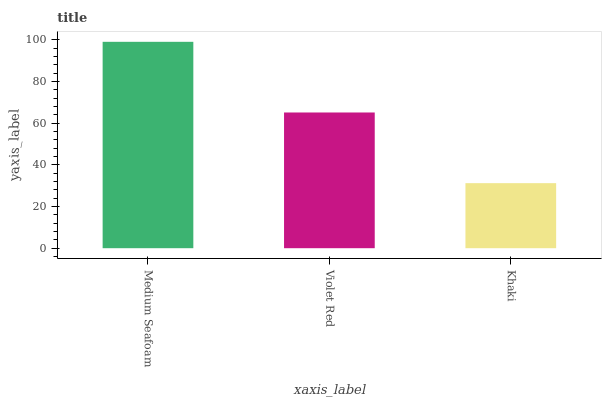Is Khaki the minimum?
Answer yes or no. Yes. Is Medium Seafoam the maximum?
Answer yes or no. Yes. Is Violet Red the minimum?
Answer yes or no. No. Is Violet Red the maximum?
Answer yes or no. No. Is Medium Seafoam greater than Violet Red?
Answer yes or no. Yes. Is Violet Red less than Medium Seafoam?
Answer yes or no. Yes. Is Violet Red greater than Medium Seafoam?
Answer yes or no. No. Is Medium Seafoam less than Violet Red?
Answer yes or no. No. Is Violet Red the high median?
Answer yes or no. Yes. Is Violet Red the low median?
Answer yes or no. Yes. Is Khaki the high median?
Answer yes or no. No. Is Khaki the low median?
Answer yes or no. No. 